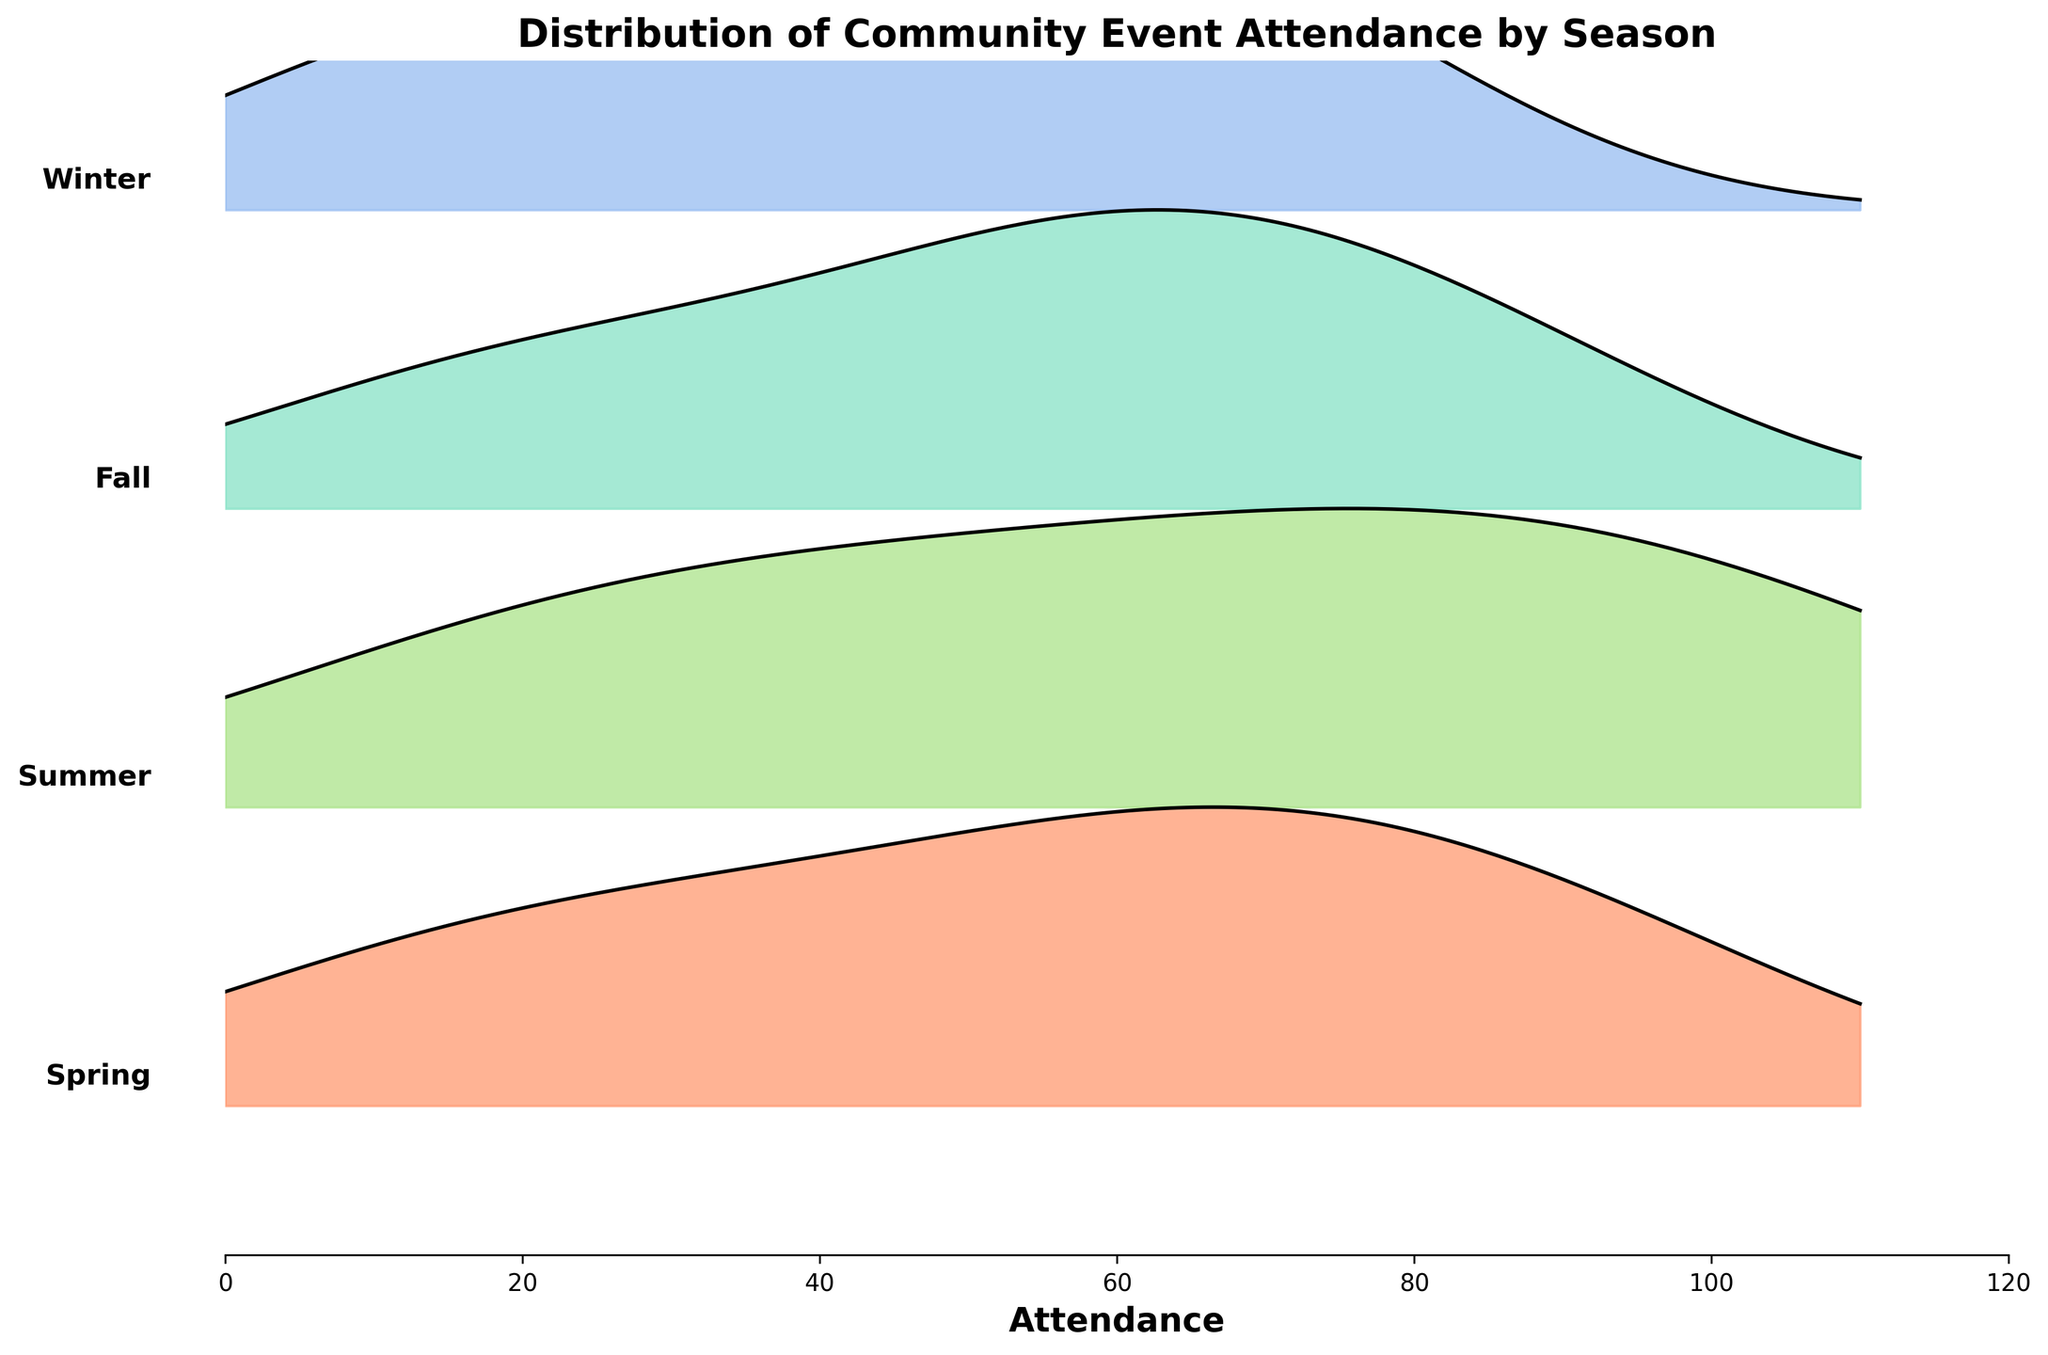What is the title of the figure? The title of the figure is displayed at the top and provides a summary of the visualized data. By looking at the top of the plot, the title "Distribution of Community Event Attendance by Season" can be seen.
Answer: Distribution of Community Event Attendance by Season Which season has the highest attendance peak in the evening? To find which season has the highest evening attendance peak, look at the height and shape of the ridges for each season around the 18:00 and 20:00 time slots. Summer has the highest peak at 18:00 with the attendance reaching 110.
Answer: Summer Compare the attendance pattern between Spring and Fall. Which season has a higher average attendance? First, observe the overall shape and height of the ridges for both Spring and Fall. Spring generally has higher ridges, indicating higher attendance at almost every time slot. Therefore, Spring has a higher average attendance than Fall.
Answer: Spring How does Winter's attendance distribution compare to Summer's? Examine the ridgeline plots for Winter and Summer. Winter has generally lower attendance across all time slots compared to Summer, which peaks significantly higher, especially in the evening at 18:00.
Answer: Winter’s attendance is generally lower than Summer’s At what time of day does attendance peak in Winter? Look at the ridgeline for Winter and find the time slot with the highest peak. The peak attendance in Winter appears around 18:00.
Answer: 18:00 Is there any season where the attendance significantly drops after 18:00? Compare the ridgelines after the 18:00 mark for all seasons. The Fall and Winter seasons show a noticeable drop in attendance after 18:00, with the ridgeline lowering significantly.
Answer: Fall and Winter Which season shows the most consistent attendance throughout the day? Observe the smoothness and uniformity of the ridgelines. Fall shows relatively flat and consistent ridgeline throughout the day compared to other seasons.
Answer: Fall What is the least attended time of day in Summer? By observing the ridgeline for Summer, the lowest trough in attendance is at 8:00 where the attendance is 15.
Answer: 8:00 How does the evening attendance in Spring compare to that in Fall? Compare the ridge height for Spring and Fall at the 18:00 and 20:00 time slots. Spring has higher ridgelines indicating higher attendance in the evening compared to Fall.
Answer: Spring has higher evening attendance 